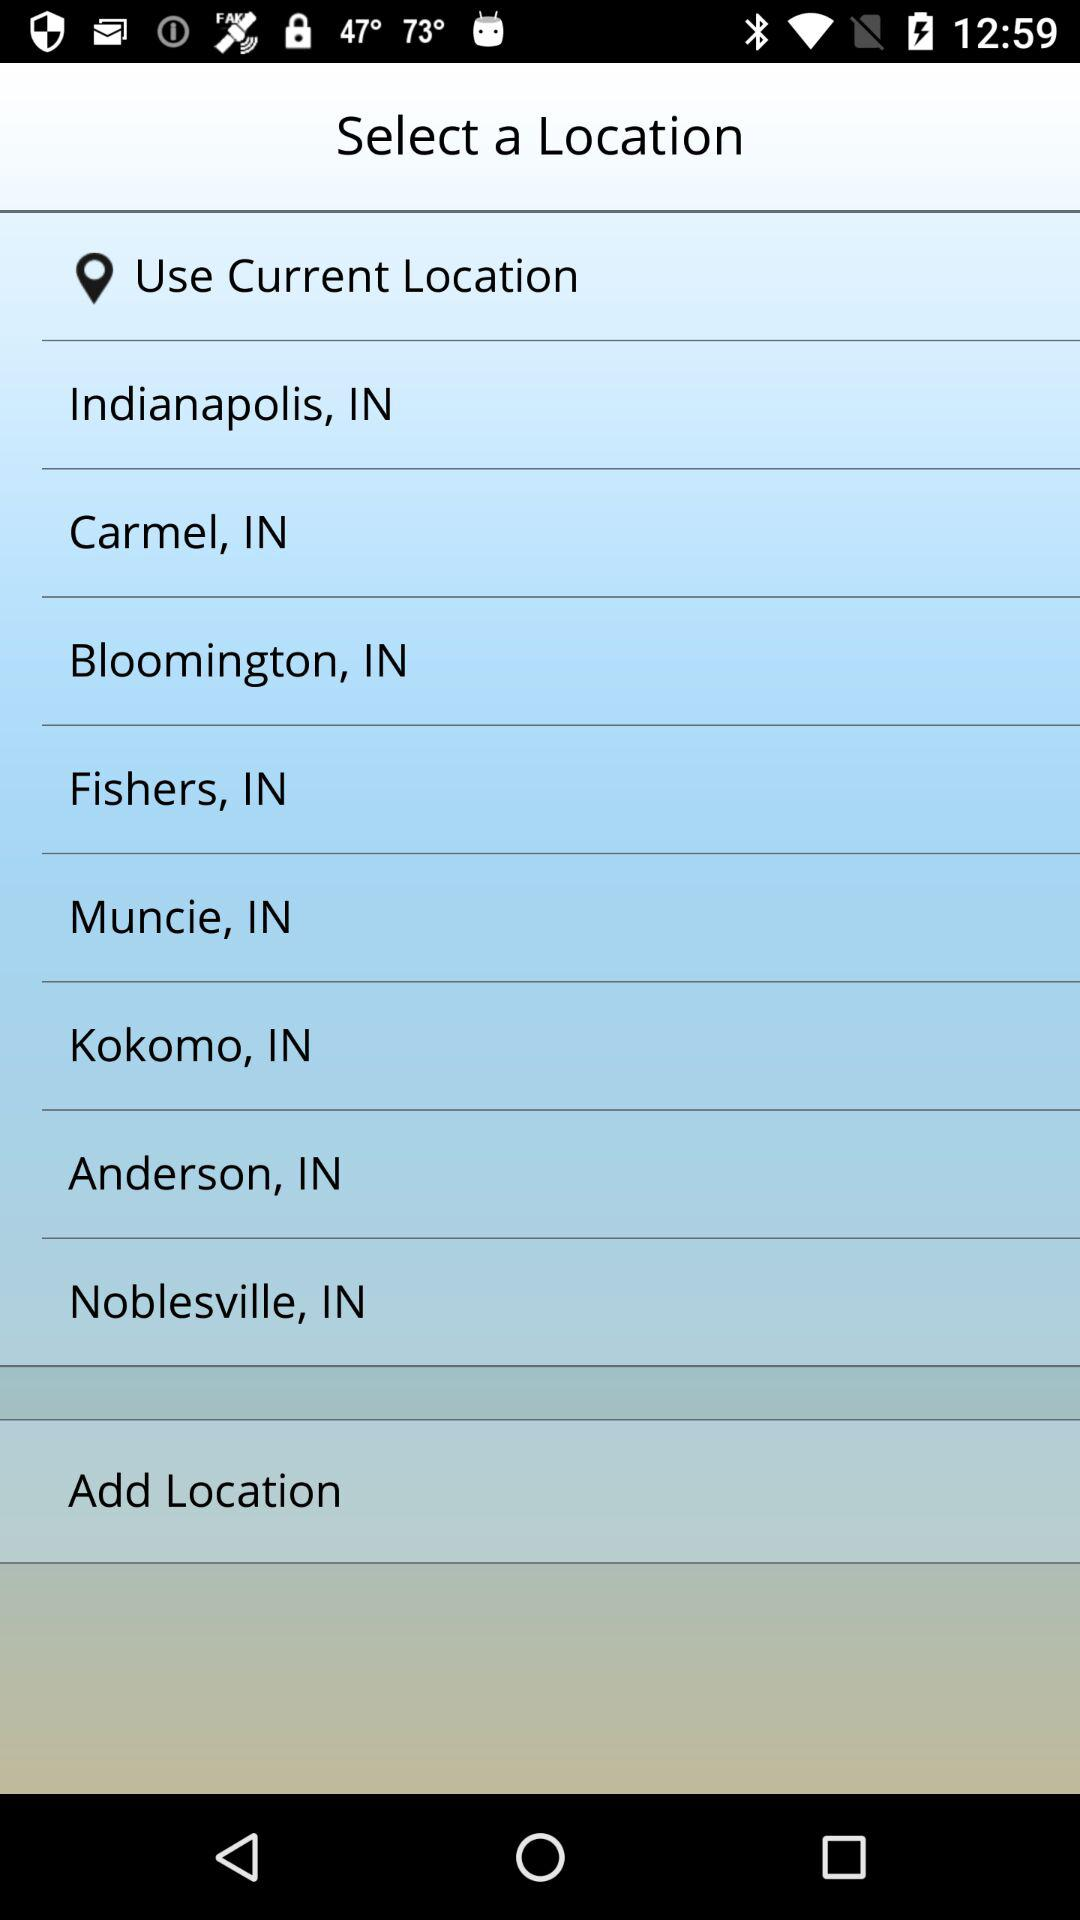How many locations are available to select from?
Answer the question using a single word or phrase. 9 